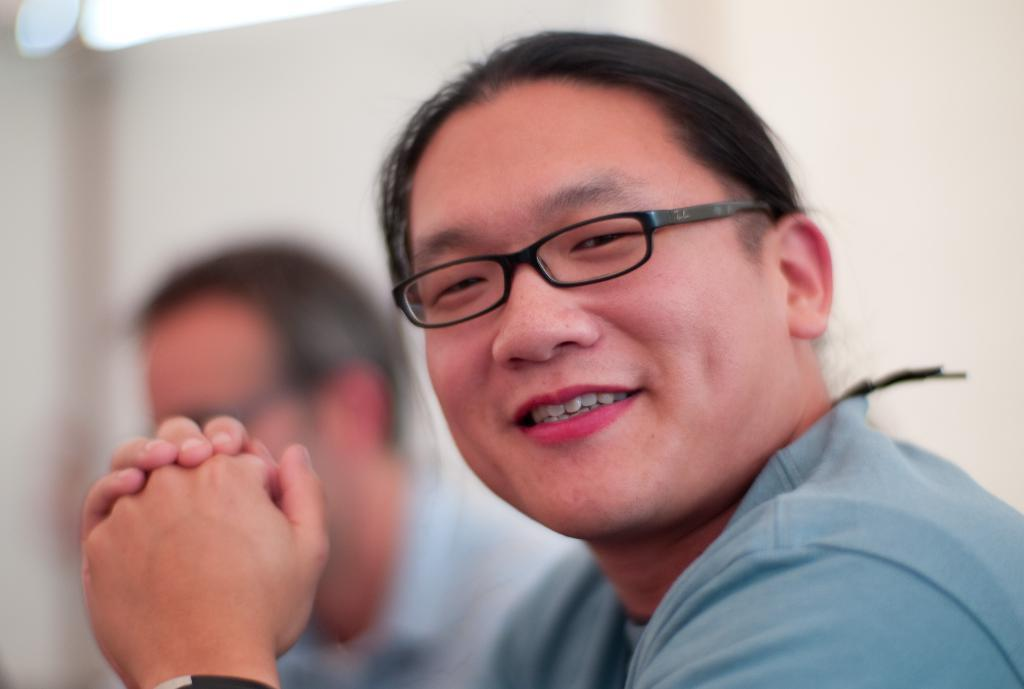What is the main subject of the image? There is a person in the image. Can you describe the person's attire? The person is wearing a grey dress and black-colored spectacles. What is the person's facial expression? The person is smiling. Are there any other people visible in the image? Yes, there is a person in the background of the image, but they are blurry. What can be seen in the background of the image? There is a white-colored wall in the background of the image, and it is blurry. What scientific experiment is the person conducting in the image? There is no scientific experiment visible in the image. Who is the person's friend in the image? There is no friend visible in the image, only a blurry person in the background. 